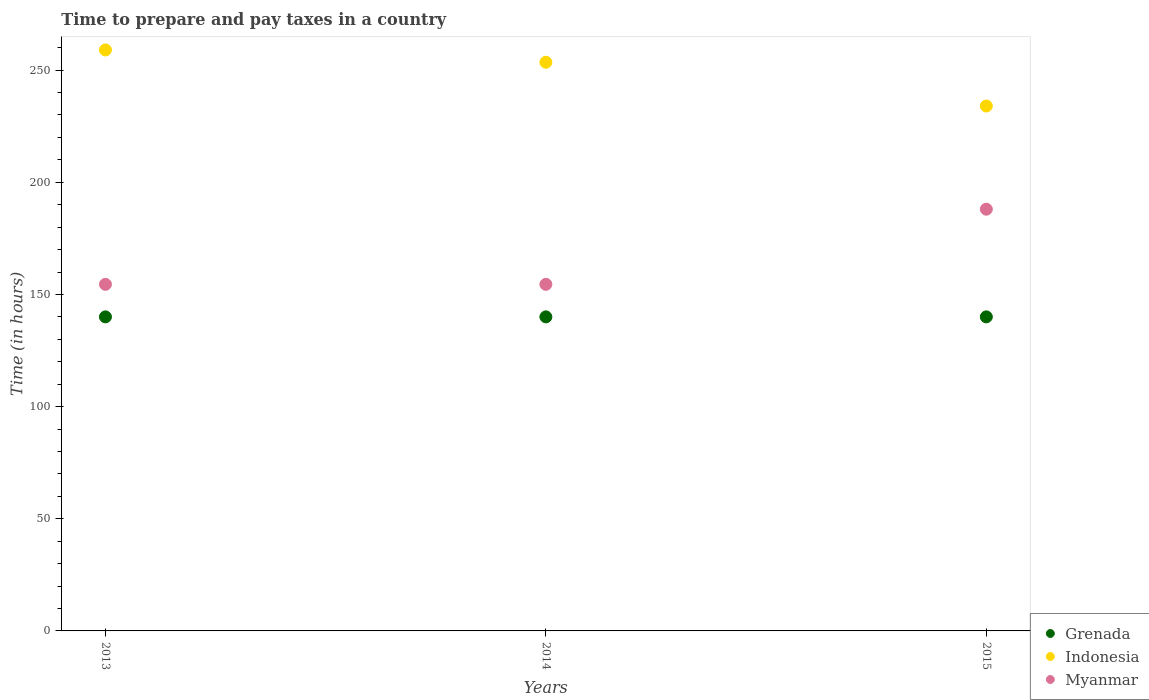What is the number of hours required to prepare and pay taxes in Grenada in 2014?
Provide a succinct answer. 140. Across all years, what is the maximum number of hours required to prepare and pay taxes in Myanmar?
Provide a short and direct response. 188. Across all years, what is the minimum number of hours required to prepare and pay taxes in Grenada?
Provide a short and direct response. 140. In which year was the number of hours required to prepare and pay taxes in Myanmar maximum?
Keep it short and to the point. 2015. What is the total number of hours required to prepare and pay taxes in Myanmar in the graph?
Provide a short and direct response. 497. What is the difference between the number of hours required to prepare and pay taxes in Myanmar in 2014 and that in 2015?
Offer a very short reply. -33.5. What is the difference between the number of hours required to prepare and pay taxes in Grenada in 2013 and the number of hours required to prepare and pay taxes in Myanmar in 2014?
Provide a succinct answer. -14.5. What is the average number of hours required to prepare and pay taxes in Indonesia per year?
Provide a short and direct response. 248.83. What is the ratio of the number of hours required to prepare and pay taxes in Grenada in 2013 to that in 2014?
Your answer should be compact. 1. Is the number of hours required to prepare and pay taxes in Myanmar in 2013 less than that in 2015?
Ensure brevity in your answer.  Yes. What is the difference between the highest and the lowest number of hours required to prepare and pay taxes in Myanmar?
Provide a succinct answer. 33.5. In how many years, is the number of hours required to prepare and pay taxes in Indonesia greater than the average number of hours required to prepare and pay taxes in Indonesia taken over all years?
Your answer should be compact. 2. Is it the case that in every year, the sum of the number of hours required to prepare and pay taxes in Indonesia and number of hours required to prepare and pay taxes in Grenada  is greater than the number of hours required to prepare and pay taxes in Myanmar?
Give a very brief answer. Yes. Is the number of hours required to prepare and pay taxes in Grenada strictly greater than the number of hours required to prepare and pay taxes in Myanmar over the years?
Offer a terse response. No. Is the number of hours required to prepare and pay taxes in Grenada strictly less than the number of hours required to prepare and pay taxes in Indonesia over the years?
Provide a succinct answer. Yes. How many dotlines are there?
Offer a terse response. 3. Are the values on the major ticks of Y-axis written in scientific E-notation?
Your answer should be very brief. No. What is the title of the graph?
Your answer should be compact. Time to prepare and pay taxes in a country. What is the label or title of the X-axis?
Your answer should be compact. Years. What is the label or title of the Y-axis?
Offer a very short reply. Time (in hours). What is the Time (in hours) in Grenada in 2013?
Provide a succinct answer. 140. What is the Time (in hours) in Indonesia in 2013?
Ensure brevity in your answer.  259. What is the Time (in hours) in Myanmar in 2013?
Give a very brief answer. 154.5. What is the Time (in hours) in Grenada in 2014?
Offer a terse response. 140. What is the Time (in hours) of Indonesia in 2014?
Offer a terse response. 253.5. What is the Time (in hours) in Myanmar in 2014?
Offer a terse response. 154.5. What is the Time (in hours) of Grenada in 2015?
Ensure brevity in your answer.  140. What is the Time (in hours) of Indonesia in 2015?
Provide a succinct answer. 234. What is the Time (in hours) in Myanmar in 2015?
Offer a very short reply. 188. Across all years, what is the maximum Time (in hours) in Grenada?
Ensure brevity in your answer.  140. Across all years, what is the maximum Time (in hours) in Indonesia?
Your response must be concise. 259. Across all years, what is the maximum Time (in hours) of Myanmar?
Keep it short and to the point. 188. Across all years, what is the minimum Time (in hours) in Grenada?
Give a very brief answer. 140. Across all years, what is the minimum Time (in hours) of Indonesia?
Make the answer very short. 234. Across all years, what is the minimum Time (in hours) of Myanmar?
Keep it short and to the point. 154.5. What is the total Time (in hours) in Grenada in the graph?
Keep it short and to the point. 420. What is the total Time (in hours) of Indonesia in the graph?
Make the answer very short. 746.5. What is the total Time (in hours) in Myanmar in the graph?
Provide a short and direct response. 497. What is the difference between the Time (in hours) in Myanmar in 2013 and that in 2014?
Provide a short and direct response. 0. What is the difference between the Time (in hours) in Indonesia in 2013 and that in 2015?
Make the answer very short. 25. What is the difference between the Time (in hours) in Myanmar in 2013 and that in 2015?
Offer a terse response. -33.5. What is the difference between the Time (in hours) in Myanmar in 2014 and that in 2015?
Your answer should be compact. -33.5. What is the difference between the Time (in hours) of Grenada in 2013 and the Time (in hours) of Indonesia in 2014?
Offer a terse response. -113.5. What is the difference between the Time (in hours) of Grenada in 2013 and the Time (in hours) of Myanmar in 2014?
Give a very brief answer. -14.5. What is the difference between the Time (in hours) in Indonesia in 2013 and the Time (in hours) in Myanmar in 2014?
Provide a succinct answer. 104.5. What is the difference between the Time (in hours) in Grenada in 2013 and the Time (in hours) in Indonesia in 2015?
Give a very brief answer. -94. What is the difference between the Time (in hours) of Grenada in 2013 and the Time (in hours) of Myanmar in 2015?
Provide a short and direct response. -48. What is the difference between the Time (in hours) of Indonesia in 2013 and the Time (in hours) of Myanmar in 2015?
Your answer should be very brief. 71. What is the difference between the Time (in hours) of Grenada in 2014 and the Time (in hours) of Indonesia in 2015?
Give a very brief answer. -94. What is the difference between the Time (in hours) of Grenada in 2014 and the Time (in hours) of Myanmar in 2015?
Make the answer very short. -48. What is the difference between the Time (in hours) of Indonesia in 2014 and the Time (in hours) of Myanmar in 2015?
Give a very brief answer. 65.5. What is the average Time (in hours) in Grenada per year?
Make the answer very short. 140. What is the average Time (in hours) in Indonesia per year?
Your answer should be very brief. 248.83. What is the average Time (in hours) of Myanmar per year?
Provide a succinct answer. 165.67. In the year 2013, what is the difference between the Time (in hours) of Grenada and Time (in hours) of Indonesia?
Provide a short and direct response. -119. In the year 2013, what is the difference between the Time (in hours) of Indonesia and Time (in hours) of Myanmar?
Offer a terse response. 104.5. In the year 2014, what is the difference between the Time (in hours) in Grenada and Time (in hours) in Indonesia?
Give a very brief answer. -113.5. In the year 2014, what is the difference between the Time (in hours) in Grenada and Time (in hours) in Myanmar?
Offer a very short reply. -14.5. In the year 2014, what is the difference between the Time (in hours) in Indonesia and Time (in hours) in Myanmar?
Provide a succinct answer. 99. In the year 2015, what is the difference between the Time (in hours) in Grenada and Time (in hours) in Indonesia?
Your answer should be compact. -94. In the year 2015, what is the difference between the Time (in hours) in Grenada and Time (in hours) in Myanmar?
Make the answer very short. -48. What is the ratio of the Time (in hours) of Grenada in 2013 to that in 2014?
Make the answer very short. 1. What is the ratio of the Time (in hours) of Indonesia in 2013 to that in 2014?
Offer a very short reply. 1.02. What is the ratio of the Time (in hours) in Grenada in 2013 to that in 2015?
Give a very brief answer. 1. What is the ratio of the Time (in hours) in Indonesia in 2013 to that in 2015?
Make the answer very short. 1.11. What is the ratio of the Time (in hours) of Myanmar in 2013 to that in 2015?
Offer a terse response. 0.82. What is the ratio of the Time (in hours) of Myanmar in 2014 to that in 2015?
Offer a very short reply. 0.82. What is the difference between the highest and the second highest Time (in hours) of Grenada?
Keep it short and to the point. 0. What is the difference between the highest and the second highest Time (in hours) of Myanmar?
Offer a terse response. 33.5. What is the difference between the highest and the lowest Time (in hours) of Indonesia?
Keep it short and to the point. 25. What is the difference between the highest and the lowest Time (in hours) in Myanmar?
Give a very brief answer. 33.5. 